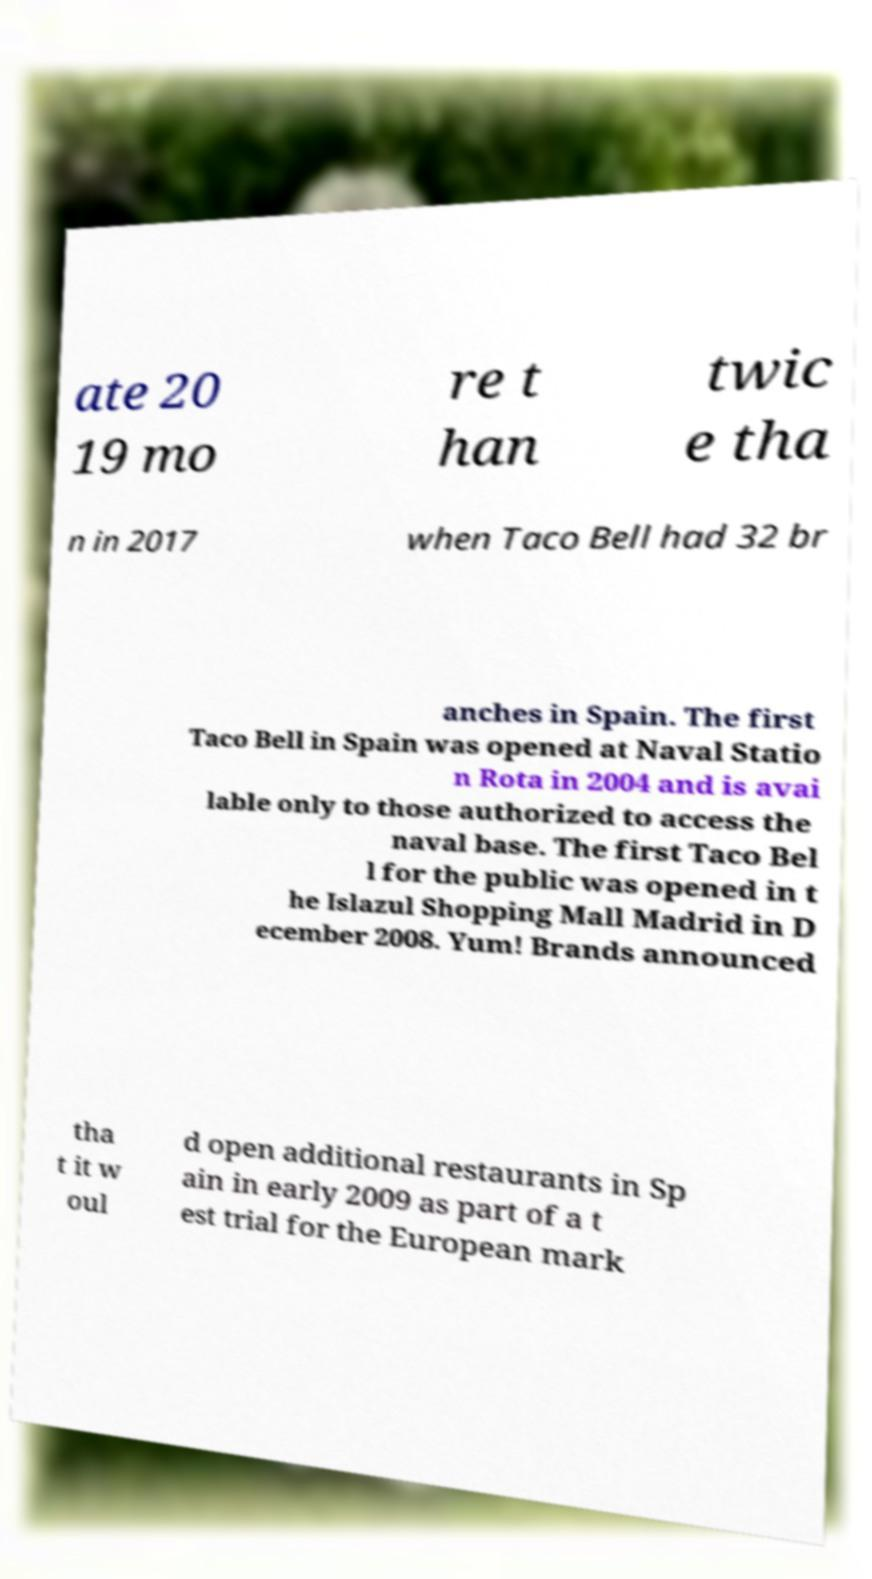Can you read and provide the text displayed in the image?This photo seems to have some interesting text. Can you extract and type it out for me? ate 20 19 mo re t han twic e tha n in 2017 when Taco Bell had 32 br anches in Spain. The first Taco Bell in Spain was opened at Naval Statio n Rota in 2004 and is avai lable only to those authorized to access the naval base. The first Taco Bel l for the public was opened in t he Islazul Shopping Mall Madrid in D ecember 2008. Yum! Brands announced tha t it w oul d open additional restaurants in Sp ain in early 2009 as part of a t est trial for the European mark 